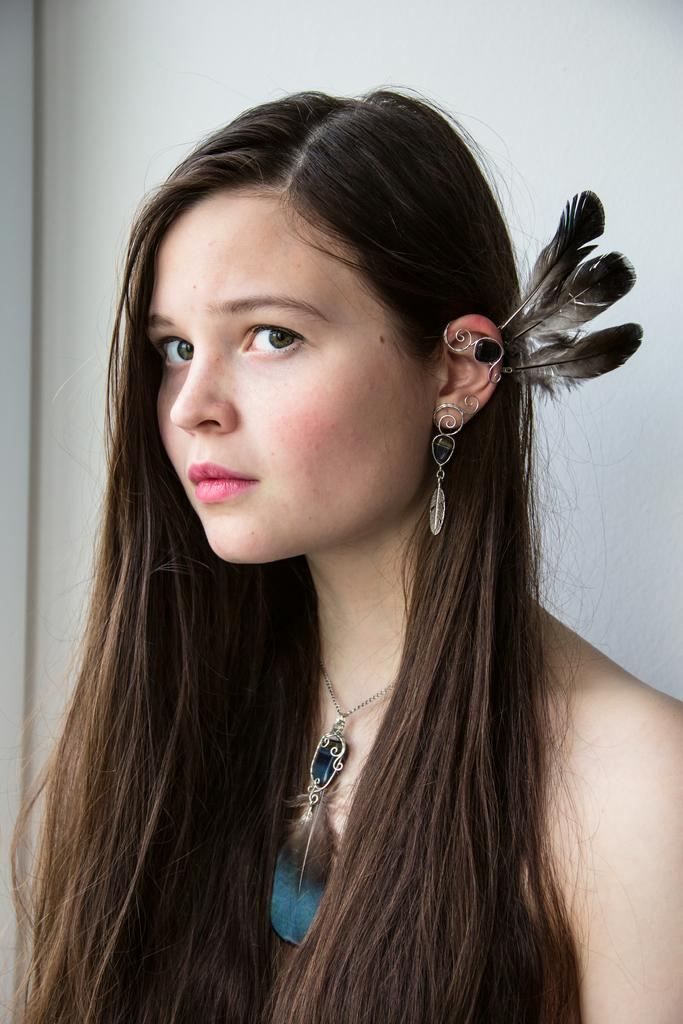Who is the main subject in the image? There is a woman in the image. What is the woman doing in the image? The woman is posing for a picture. Can you describe any accessories the woman is wearing? The woman is wearing a locket around her neck. What can be seen in the background of the image? There is a wall in the background of the image. What arithmetic problem is the woman solving in the image? There is no arithmetic problem visible in the image. How many visitors are present in the image? There is no indication of any visitors in the image; it only features the woman. 